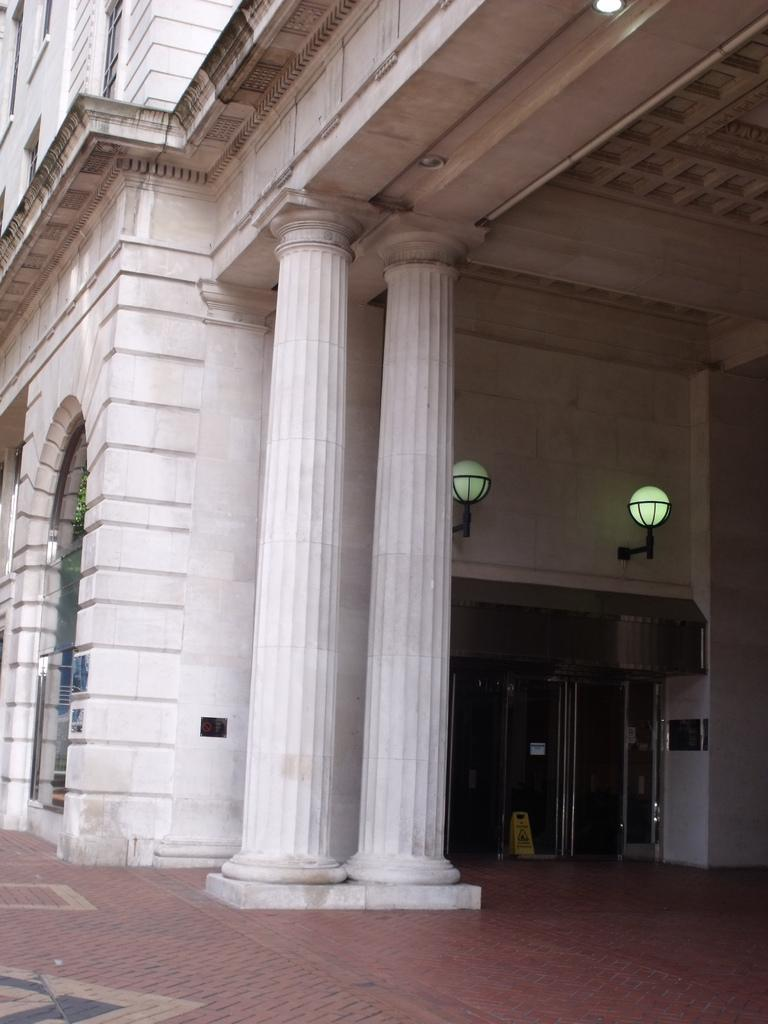What is the main structure in the center of the image? There is a building in the center of the image. What architectural feature can be seen in the image? There is a wall in the image. What can be seen illuminating the area in the image? Lights are present in the image. What type of support structure is visible in the image? Pillars are visible in the image. What type of decorative elements are present in the image? Banners are in the image. What type of entrance is visible in the image? There is a glass door in the image. What type of mask is being worn by the worm in the image? There is no worm or mask present in the image. How is the comb being used in the image? There is no comb present in the image. 